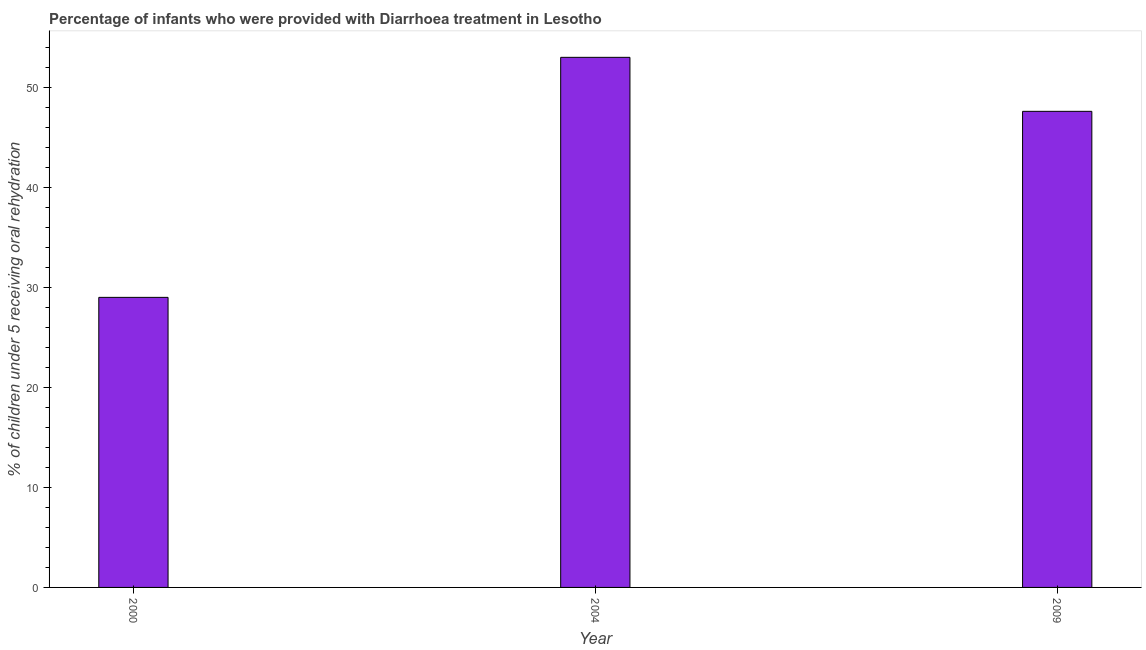Does the graph contain any zero values?
Provide a succinct answer. No. Does the graph contain grids?
Your answer should be compact. No. What is the title of the graph?
Give a very brief answer. Percentage of infants who were provided with Diarrhoea treatment in Lesotho. What is the label or title of the Y-axis?
Offer a terse response. % of children under 5 receiving oral rehydration. What is the percentage of children who were provided with treatment diarrhoea in 2004?
Provide a short and direct response. 53. Across all years, what is the minimum percentage of children who were provided with treatment diarrhoea?
Your response must be concise. 29. What is the sum of the percentage of children who were provided with treatment diarrhoea?
Keep it short and to the point. 129.6. What is the difference between the percentage of children who were provided with treatment diarrhoea in 2000 and 2009?
Make the answer very short. -18.6. What is the average percentage of children who were provided with treatment diarrhoea per year?
Your answer should be very brief. 43.2. What is the median percentage of children who were provided with treatment diarrhoea?
Your response must be concise. 47.6. Do a majority of the years between 2000 and 2009 (inclusive) have percentage of children who were provided with treatment diarrhoea greater than 42 %?
Offer a very short reply. Yes. What is the ratio of the percentage of children who were provided with treatment diarrhoea in 2004 to that in 2009?
Offer a terse response. 1.11. Is the sum of the percentage of children who were provided with treatment diarrhoea in 2000 and 2009 greater than the maximum percentage of children who were provided with treatment diarrhoea across all years?
Offer a terse response. Yes. How many bars are there?
Your response must be concise. 3. How many years are there in the graph?
Your answer should be compact. 3. What is the % of children under 5 receiving oral rehydration of 2004?
Offer a terse response. 53. What is the % of children under 5 receiving oral rehydration in 2009?
Offer a very short reply. 47.6. What is the difference between the % of children under 5 receiving oral rehydration in 2000 and 2004?
Keep it short and to the point. -24. What is the difference between the % of children under 5 receiving oral rehydration in 2000 and 2009?
Give a very brief answer. -18.6. What is the ratio of the % of children under 5 receiving oral rehydration in 2000 to that in 2004?
Give a very brief answer. 0.55. What is the ratio of the % of children under 5 receiving oral rehydration in 2000 to that in 2009?
Your response must be concise. 0.61. What is the ratio of the % of children under 5 receiving oral rehydration in 2004 to that in 2009?
Keep it short and to the point. 1.11. 